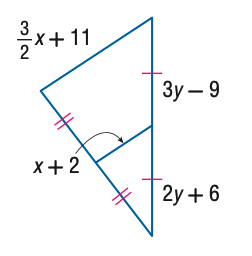Answer the mathemtical geometry problem and directly provide the correct option letter.
Question: Find x.
Choices: A: 8 B: 10 C: 12 D: 14 D 